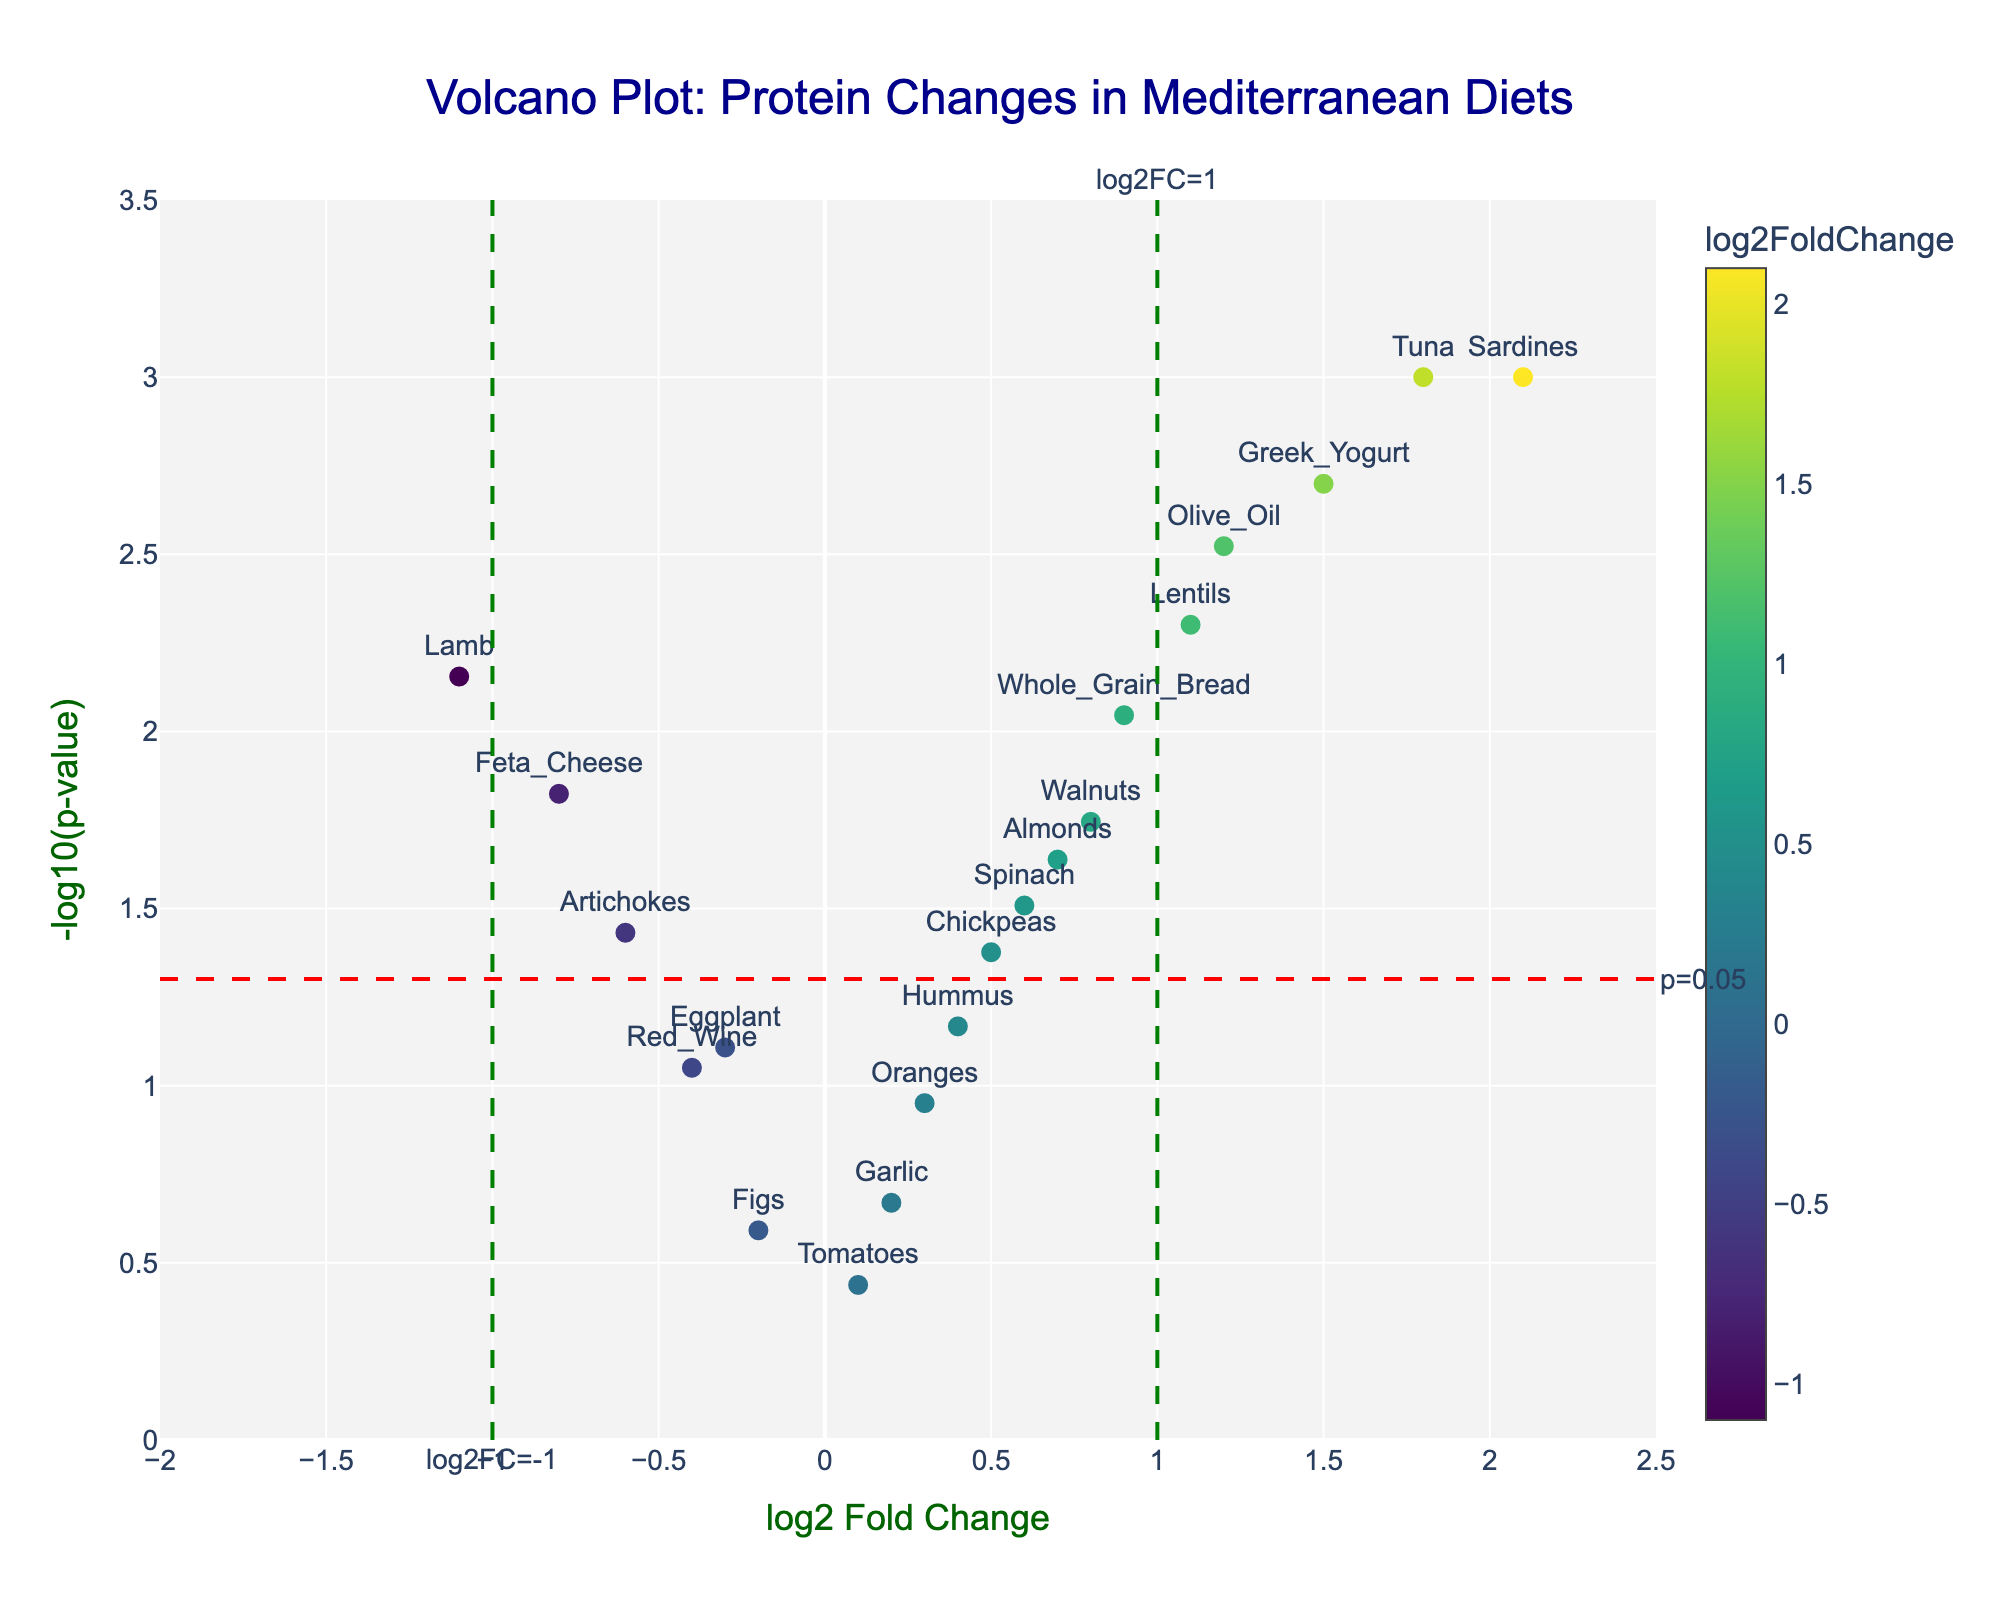What's the title of the plot? The title is usually displayed at the top of the plot. It helps the viewer understand what the plot represents. In this case, it reads: "Volcano Plot: Protein Changes in Mediterranean Diets".
Answer: Volcano Plot: Protein Changes in Mediterranean Diets What are the axes' labels? The x-axis label is typically horizontal at the bottom and indicates the variable being measured. The y-axis label is vertical on the left side and represents another measured variable. In this plot, they are "log2 Fold Change" and "-log10(p-value)", respectively.
Answer: log2 Fold Change and -log10(p-value) Which protein has the highest log2 fold change and what is its value? The highest log2 fold change can be found by looking at the furthest right point on the x-axis. Here it is "Sardines" with a log2 fold change of 2.1.
Answer: Sardines, 2.1 Which points fall above the significance threshold of p=0.05? The significance threshold is indicated by a horizontal red dashed line. Points above this line have p-values less than 0.05. These points are "Olive_Oil," "Sardines," "Whole_Grain_Bread," "Greek_Yogurt," "Lentils," "Spinach," "Walnuts," and "Lamb".
Answer: Olive_Oil, Sardines, Whole_Grain_Bread, Greek_Yogurt, Lentils, Spinach, Walnuts, Lamb Which protein indicates the most significant change with a negative log2 fold change and what is its value? The most significant negative change can be determined by locating the point furthest left on the x-axis and above the significance threshold. This point is "Lamb" with a log2 fold change of -1.1.
Answer: Lamb, -1.1 How many proteins have a log2 fold change greater than 1? To find this, count the points on the right side of the log2 fold change threshold line at x=1. These are "Sardines," "Greek_Yogurt," and "Tuna". Therefore, there are 3 proteins.
Answer: 3 Which protein has the lowest p-value and what is its value? The p-value is represented by the y-axis as -log10(p-value). The highest point on the plot indicates the smallest p-value. This is "Sardines" with a p-value of 0.001.
Answer: Sardines, 0.001 What is the range of log2 fold change values on the x-axis? The range can be identified by looking at the x-axis scale. The minimum is -2 and the maximum is 2.5.
Answer: -2 to 2.5 Compare the log2 fold change of Olive Oil and Feta Cheese. Which one shows a greater change and by how much? Olive Oil and Feta Cheese have log2 fold changes of 1.2 and -0.8, respectively. The difference is 1.2 - (-0.8) = 2.0. Therefore, Olive Oil shows a greater change by 2.0.
Answer: Olive Oil by 2.0 Are there any proteins that have a log2 fold change close to zero but are statistically significant? Proteins close to zero on the x-axis but above the significance threshold line are of interest. "Chickpeas" with log2 fold change of 0.5 and "Spinach" with log2 fold change of 0.6 are both statistically significant (p<0.05).
Answer: Chickpeas, Spinach 